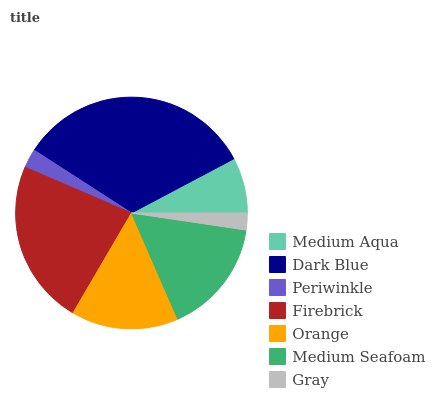Is Gray the minimum?
Answer yes or no. Yes. Is Dark Blue the maximum?
Answer yes or no. Yes. Is Periwinkle the minimum?
Answer yes or no. No. Is Periwinkle the maximum?
Answer yes or no. No. Is Dark Blue greater than Periwinkle?
Answer yes or no. Yes. Is Periwinkle less than Dark Blue?
Answer yes or no. Yes. Is Periwinkle greater than Dark Blue?
Answer yes or no. No. Is Dark Blue less than Periwinkle?
Answer yes or no. No. Is Orange the high median?
Answer yes or no. Yes. Is Orange the low median?
Answer yes or no. Yes. Is Medium Seafoam the high median?
Answer yes or no. No. Is Medium Seafoam the low median?
Answer yes or no. No. 